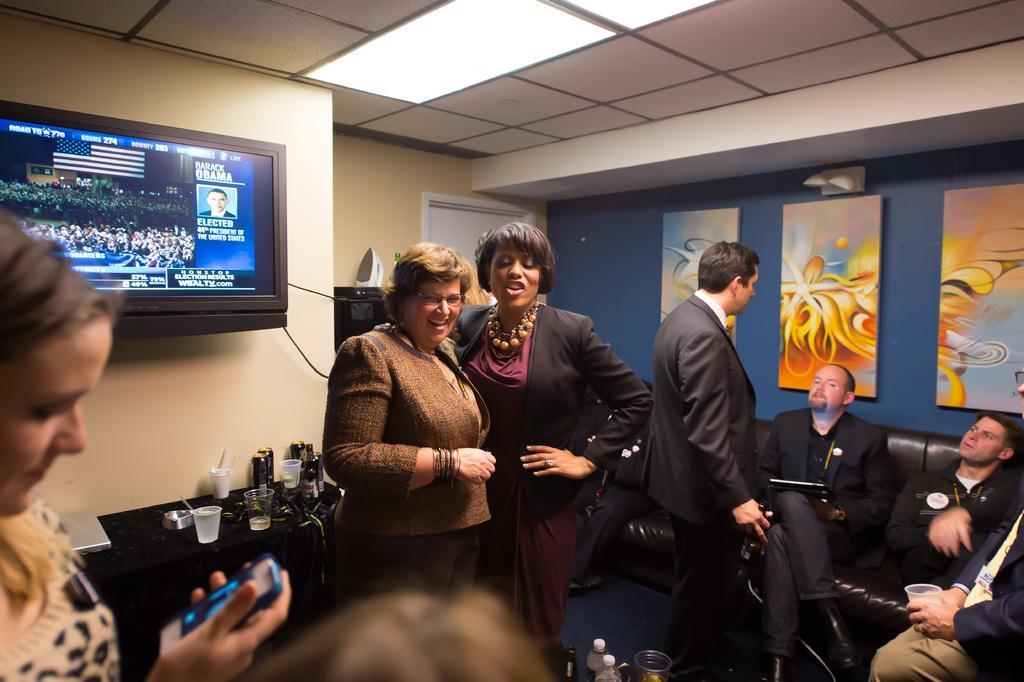Could you give a brief overview of what you see in this image? In the image we can see there are people sitting on the sofa and there are portraits kept on the wall. There is tv on the wall and there are glasses kept on the table. 